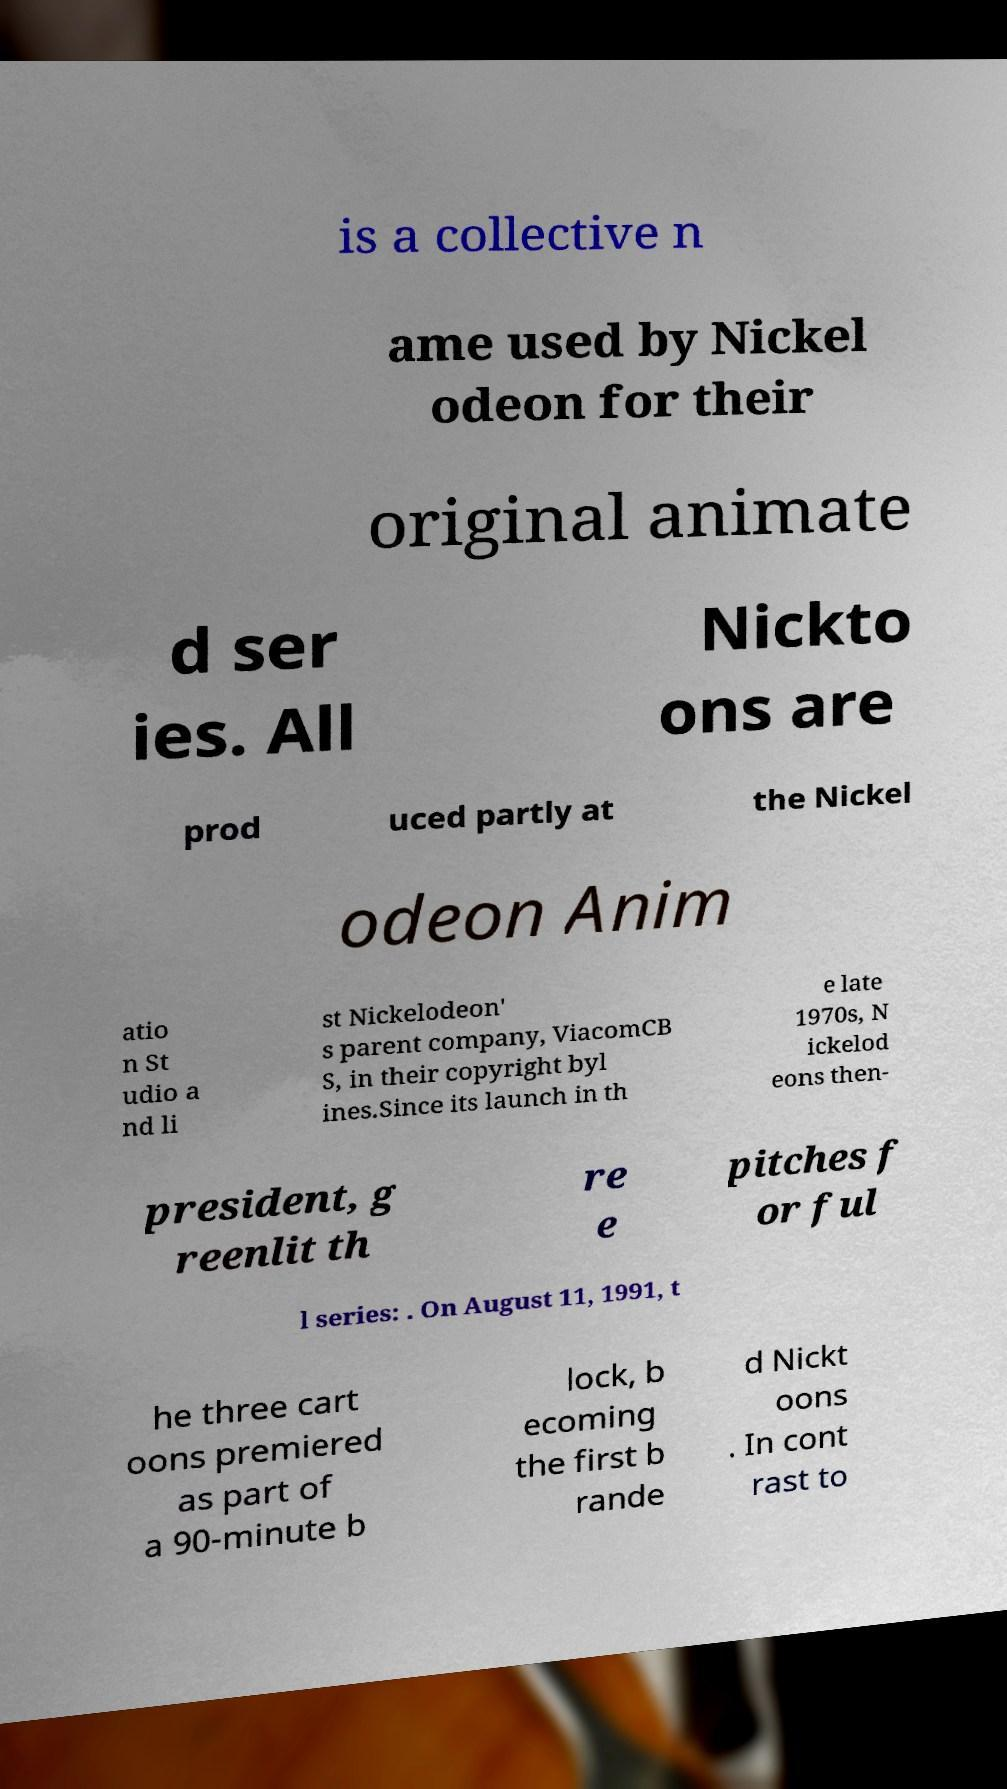There's text embedded in this image that I need extracted. Can you transcribe it verbatim? is a collective n ame used by Nickel odeon for their original animate d ser ies. All Nickto ons are prod uced partly at the Nickel odeon Anim atio n St udio a nd li st Nickelodeon' s parent company, ViacomCB S, in their copyright byl ines.Since its launch in th e late 1970s, N ickelod eons then- president, g reenlit th re e pitches f or ful l series: . On August 11, 1991, t he three cart oons premiered as part of a 90-minute b lock, b ecoming the first b rande d Nickt oons . In cont rast to 